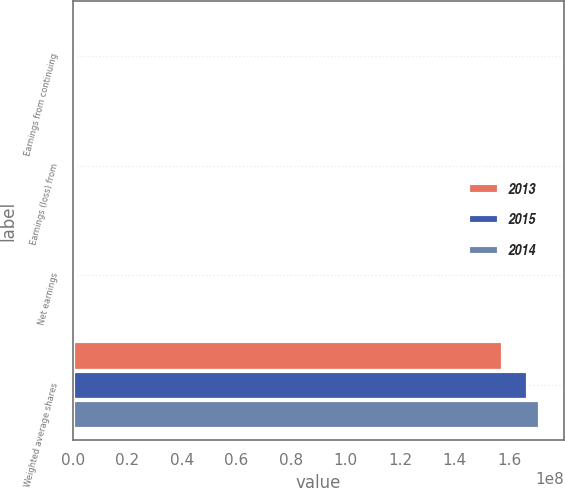<chart> <loc_0><loc_0><loc_500><loc_500><stacked_bar_chart><ecel><fcel>Earnings from continuing<fcel>Earnings (loss) from<fcel>Net earnings<fcel>Weighted average shares<nl><fcel>2013<fcel>595881<fcel>273948<fcel>869829<fcel>1.57619e+08<nl><fcel>2015<fcel>778140<fcel>2905<fcel>775235<fcel>1.66692e+08<nl><fcel>2014<fcel>797527<fcel>205602<fcel>1.00313e+06<fcel>1.71271e+08<nl></chart> 